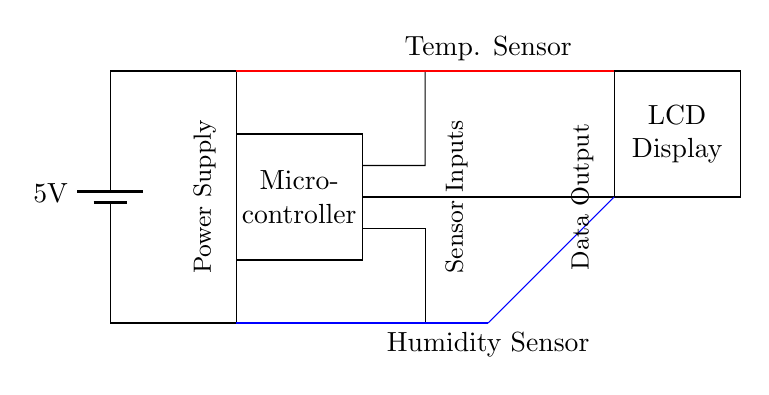What is the voltage of the power supply? The circuit specifies a battery providing a voltage of 5 volts. This can be identified as the first component in the diagram.
Answer: 5 volts What type of sensors are included in the circuit? The circuit includes a temperature sensor, identified as a thermistor, and a humidity sensor, labeled as a generic sensor. Both sensors are represented in the circuit.
Answer: Temperature sensor and humidity sensor How many components are connected to the microcontroller? The microcontroller is connected to three components: the temperature sensor, the humidity sensor, and the LCD display, as indicated by the connections extending from the microcontroller.
Answer: Three components What is the function of the LCD display in this circuit? The LCD display serves as the data output component, providing a visual representation of the temperature and humidity readings collected from the sensors. This function can be inferred from its labeling and connection to the microcontroller.
Answer: Data output What type of circuit is represented here? This circuit is designed for low power applications, specifically for monitoring temperature and humidity in a greenhouse setting, which can be deduced from its components focused on environmental control.
Answer: Low power circuit How are the sensor outputs connected to the microcontroller? The outputs of both the temperature sensor and humidity sensor are connected to the microcontroller through dedicated input lines, shown as distinct connections in the circuit diagram. This indicates the flow of data from the sensors to the microcontroller for processing.
Answer: Through dedicated input lines What is the purpose of the battery in this circuit? The battery provides the necessary voltage and power to operate the entire circuit, ensuring that all components, including sensors and microcontroller, function properly. Its role as a power supply is the primary characteristic of the circuit's design.
Answer: Power supply 